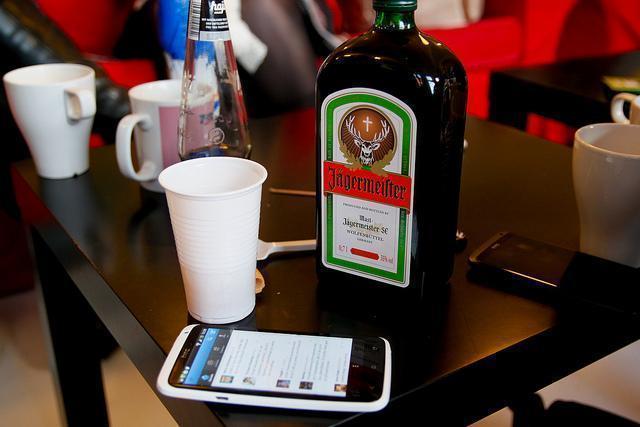What athlete has a last name that is similar to the name on the bottle?
From the following set of four choices, select the accurate answer to respond to the question.
Options: Otis nixon, mike richter, jaromir jagr, ben hogan. Jaromir jagr. 